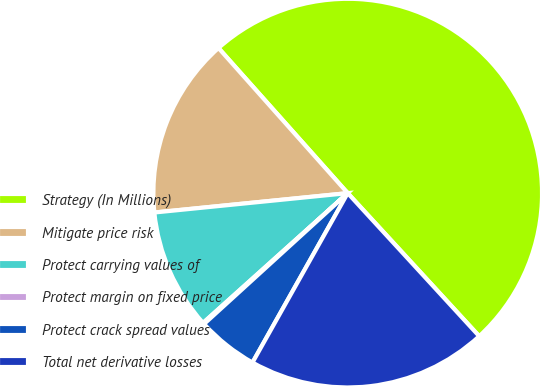Convert chart to OTSL. <chart><loc_0><loc_0><loc_500><loc_500><pie_chart><fcel>Strategy (In Millions)<fcel>Mitigate price risk<fcel>Protect carrying values of<fcel>Protect margin on fixed price<fcel>Protect crack spread values<fcel>Total net derivative losses<nl><fcel>49.75%<fcel>15.01%<fcel>10.05%<fcel>0.12%<fcel>5.09%<fcel>19.98%<nl></chart> 